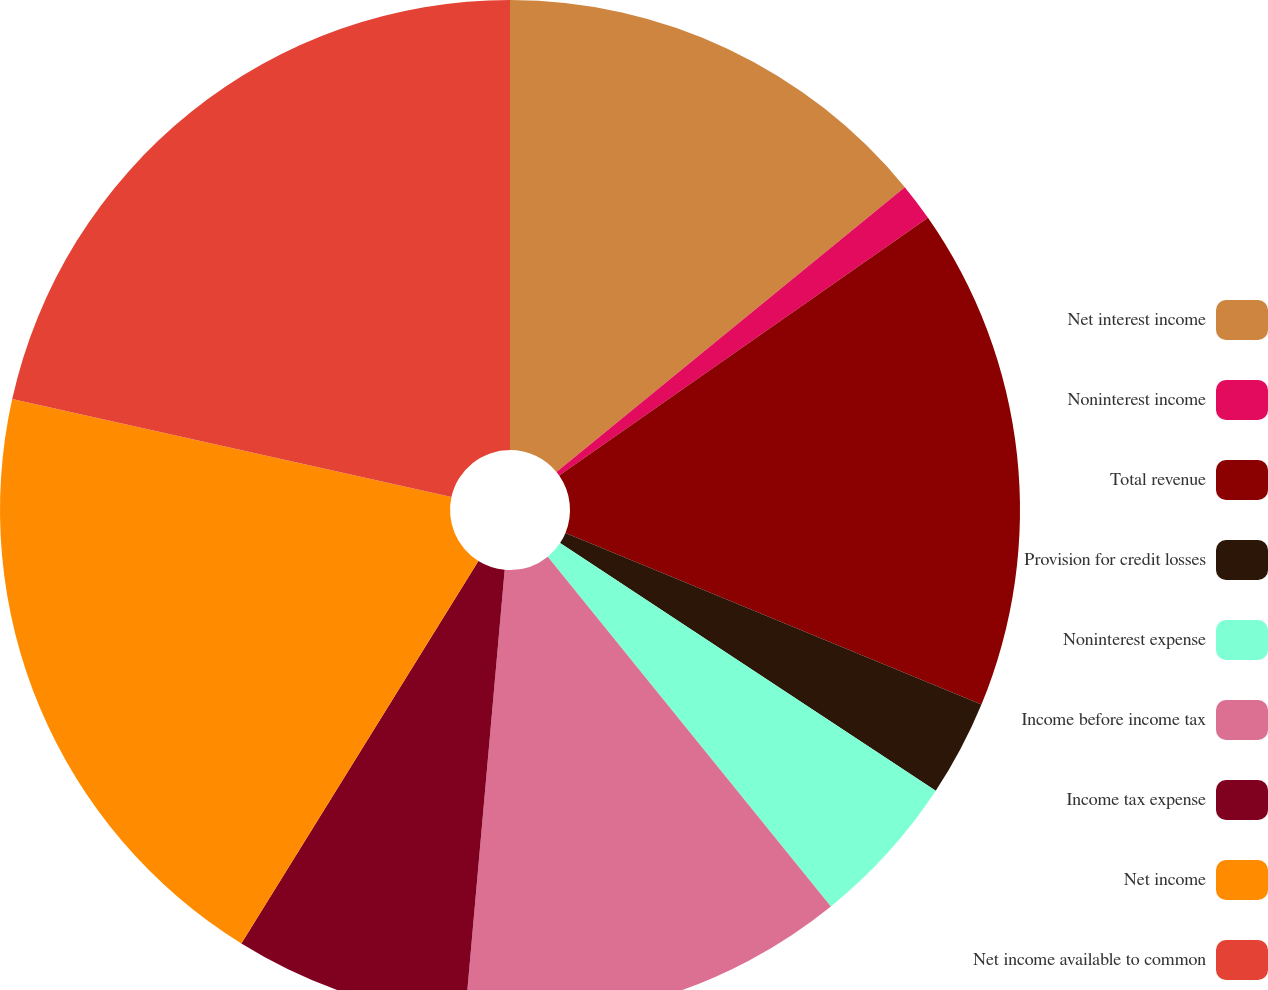<chart> <loc_0><loc_0><loc_500><loc_500><pie_chart><fcel>Net interest income<fcel>Noninterest income<fcel>Total revenue<fcel>Provision for credit losses<fcel>Noninterest expense<fcel>Income before income tax<fcel>Income tax expense<fcel>Net income<fcel>Net income available to common<nl><fcel>14.09%<fcel>1.2%<fcel>15.94%<fcel>3.05%<fcel>4.89%<fcel>12.24%<fcel>7.42%<fcel>19.66%<fcel>21.51%<nl></chart> 